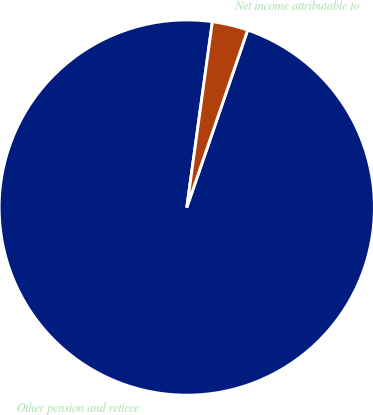<chart> <loc_0><loc_0><loc_500><loc_500><pie_chart><fcel>Other pension and retiree<fcel>Net income attributable to<nl><fcel>96.92%<fcel>3.08%<nl></chart> 